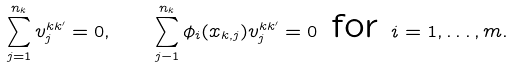<formula> <loc_0><loc_0><loc_500><loc_500>\sum _ { j = 1 } ^ { n _ { k } } v ^ { k k ^ { \prime } } _ { j } = 0 , \quad \sum _ { j - 1 } ^ { n _ { k } } \phi _ { i } ( x _ { k , j } ) v ^ { k k ^ { \prime } } _ { j } = 0 \text { for } i = 1 , \dots , m .</formula> 